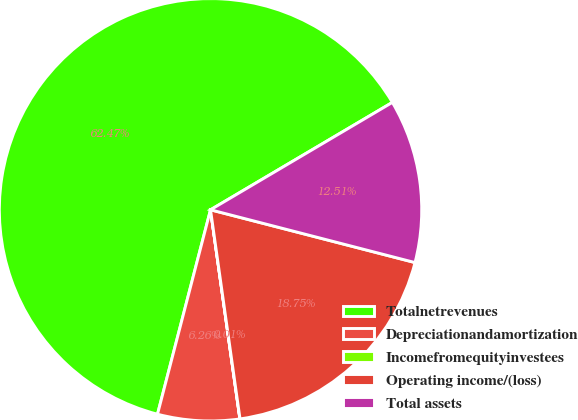Convert chart to OTSL. <chart><loc_0><loc_0><loc_500><loc_500><pie_chart><fcel>Totalnetrevenues<fcel>Depreciationandamortization<fcel>Incomefromequityinvestees<fcel>Operating income/(loss)<fcel>Total assets<nl><fcel>62.47%<fcel>6.26%<fcel>0.01%<fcel>18.75%<fcel>12.51%<nl></chart> 